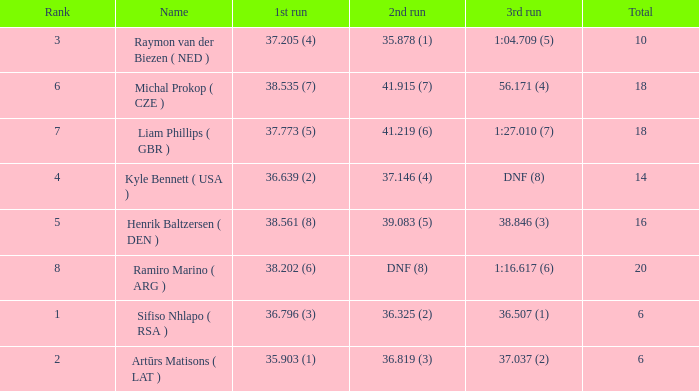Which 3rd run has rank of 1? 36.507 (1). 